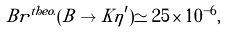Convert formula to latex. <formula><loc_0><loc_0><loc_500><loc_500>B r ^ { t h e o . } ( B \to K \eta ^ { \prime } ) \simeq 2 5 \times 1 0 ^ { - 6 } ,</formula> 